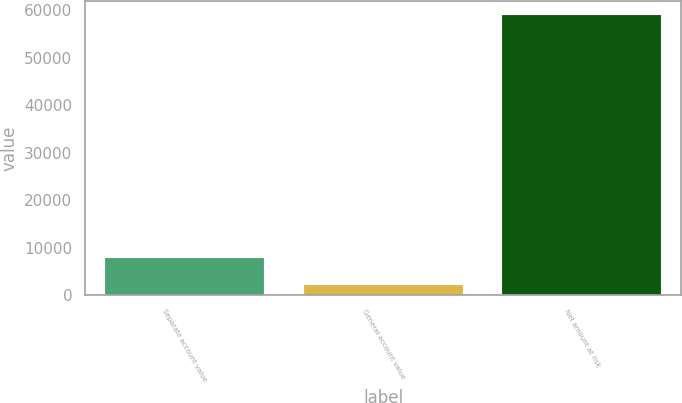Convert chart. <chart><loc_0><loc_0><loc_500><loc_500><bar_chart><fcel>Separate account value<fcel>General account value<fcel>Net amount at risk<nl><fcel>7882.2<fcel>2201<fcel>59013<nl></chart> 